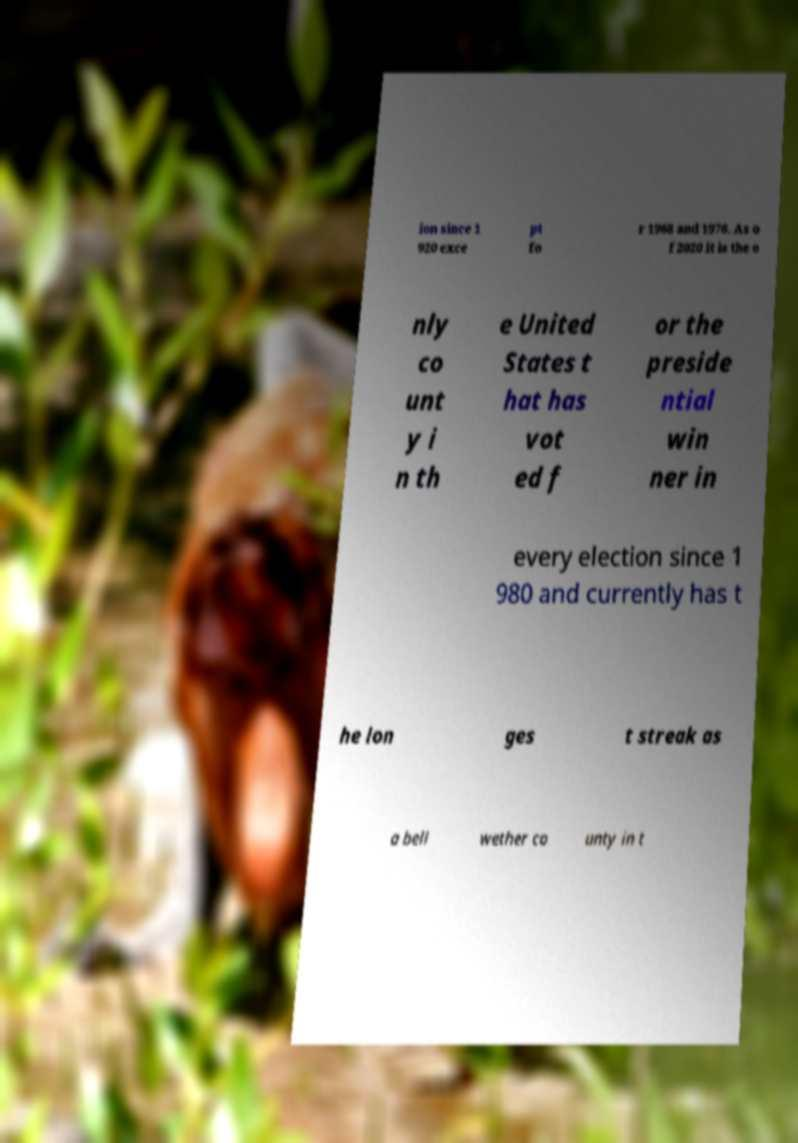Please identify and transcribe the text found in this image. ion since 1 920 exce pt fo r 1968 and 1976. As o f 2020 it is the o nly co unt y i n th e United States t hat has vot ed f or the preside ntial win ner in every election since 1 980 and currently has t he lon ges t streak as a bell wether co unty in t 